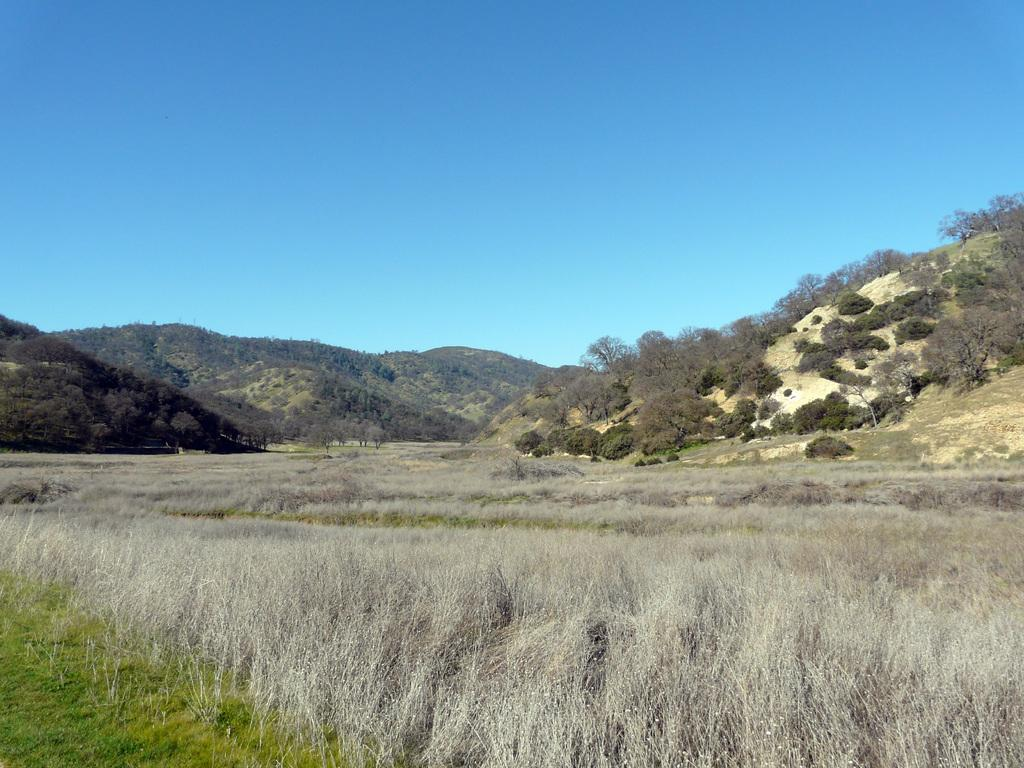What type of living organisms can be seen in the image? Plants can be seen in the image. What geographical features are present in the image? There are hills with trees in the image. What type of learning is taking place in the image? There is no indication of any learning activity in the image; it primarily features plants and hills with trees. 